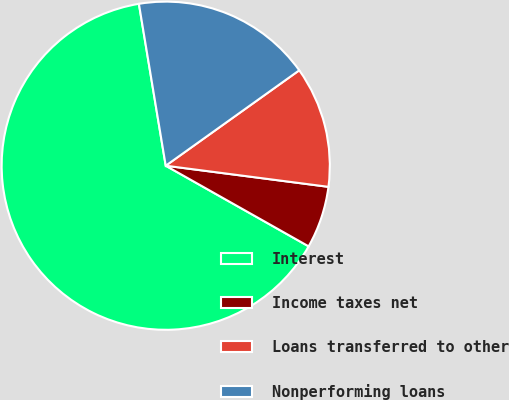Convert chart. <chart><loc_0><loc_0><loc_500><loc_500><pie_chart><fcel>Interest<fcel>Income taxes net<fcel>Loans transferred to other<fcel>Nonperforming loans<nl><fcel>64.21%<fcel>6.12%<fcel>11.93%<fcel>17.74%<nl></chart> 